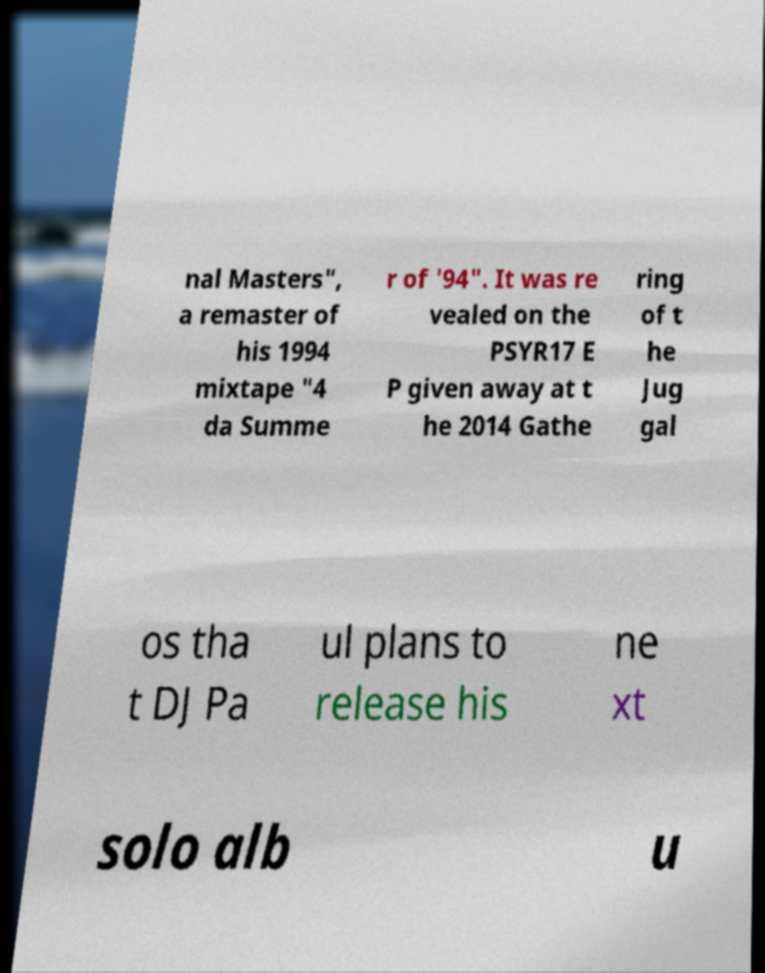For documentation purposes, I need the text within this image transcribed. Could you provide that? nal Masters", a remaster of his 1994 mixtape "4 da Summe r of '94". It was re vealed on the PSYR17 E P given away at t he 2014 Gathe ring of t he Jug gal os tha t DJ Pa ul plans to release his ne xt solo alb u 